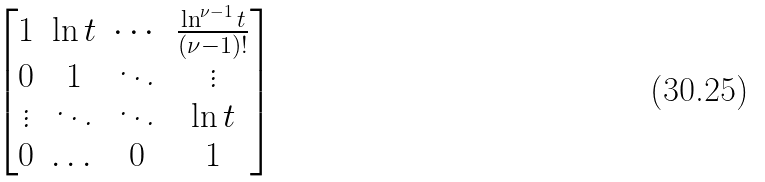Convert formula to latex. <formula><loc_0><loc_0><loc_500><loc_500>\begin{bmatrix} 1 & \ln t & \cdots & \frac { \ln ^ { \nu - 1 } t } { ( \nu - 1 ) ! } \\ 0 & 1 & \ddots & \vdots \\ \vdots & \ddots & \ddots & \ln t \\ 0 & \dots & 0 & 1 \end{bmatrix}</formula> 